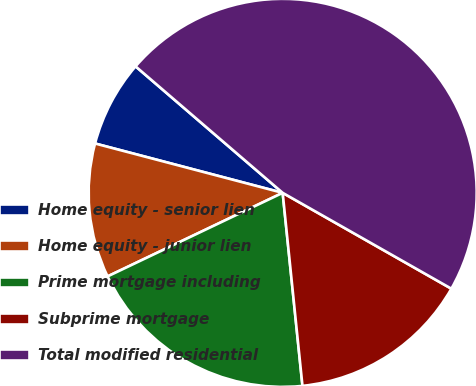Convert chart to OTSL. <chart><loc_0><loc_0><loc_500><loc_500><pie_chart><fcel>Home equity - senior lien<fcel>Home equity - junior lien<fcel>Prime mortgage including<fcel>Subprime mortgage<fcel>Total modified residential<nl><fcel>7.21%<fcel>11.18%<fcel>19.54%<fcel>15.15%<fcel>46.92%<nl></chart> 